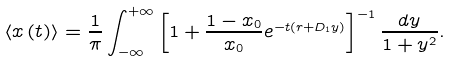Convert formula to latex. <formula><loc_0><loc_0><loc_500><loc_500>\left \langle x \left ( t \right ) \right \rangle = \frac { 1 } { \pi } \int \nolimits _ { - \infty } ^ { + \infty } \left [ 1 + \frac { 1 - x _ { 0 } } { x _ { 0 } } e ^ { - t \left ( r + D _ { 1 } y \right ) } \right ] ^ { - 1 } \frac { d y } { 1 + y ^ { 2 } } .</formula> 